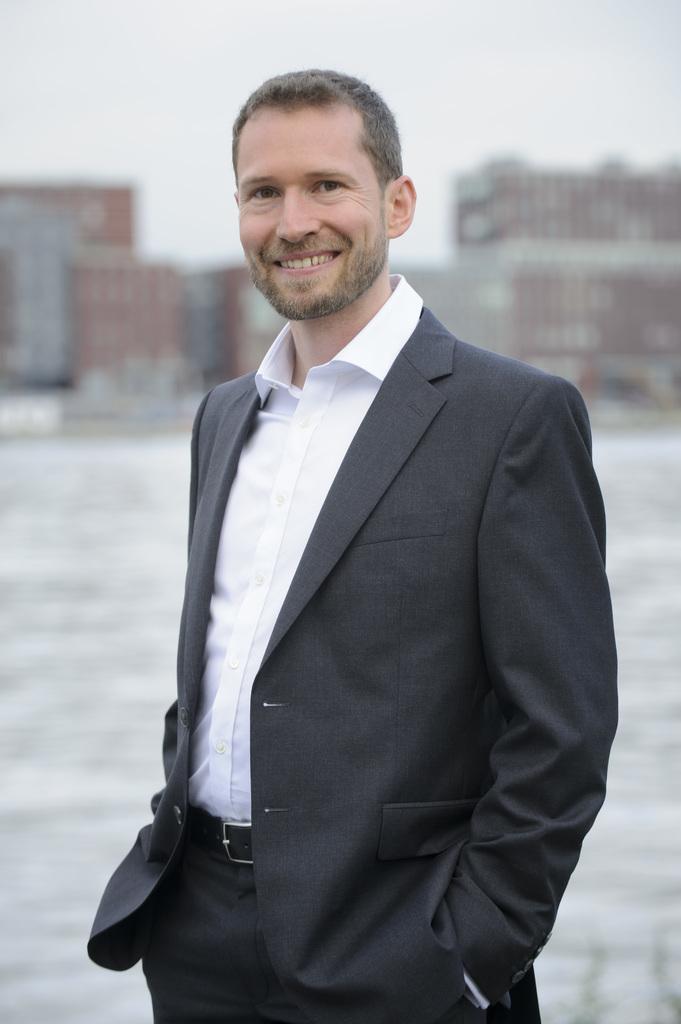Can you describe this image briefly? In the image there is man in black suit and white shirt standing and behind him it seems to be a building and above its sky. 